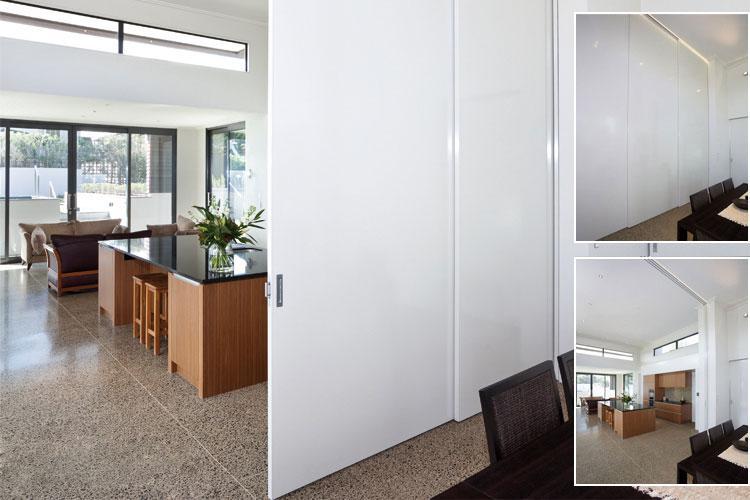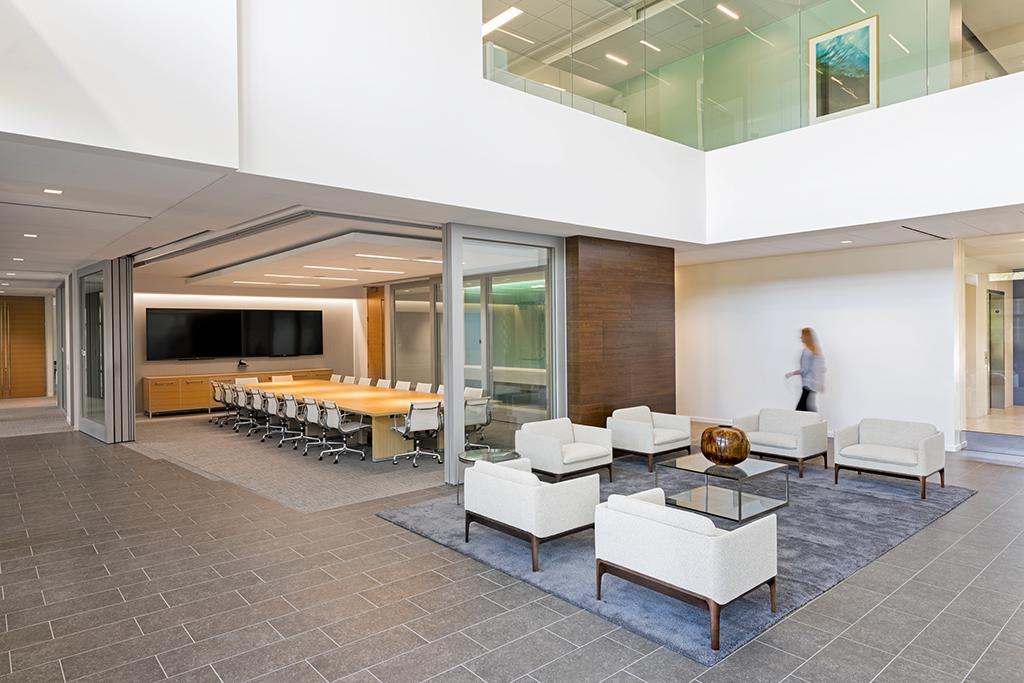The first image is the image on the left, the second image is the image on the right. Given the left and right images, does the statement "In at  least one image there is a half open light brown wooden door that opens from the right." hold true? Answer yes or no. No. The first image is the image on the left, the second image is the image on the right. Analyze the images presented: Is the assertion "An image shows solid white sliding doors that open into a room with wood furniture." valid? Answer yes or no. Yes. 